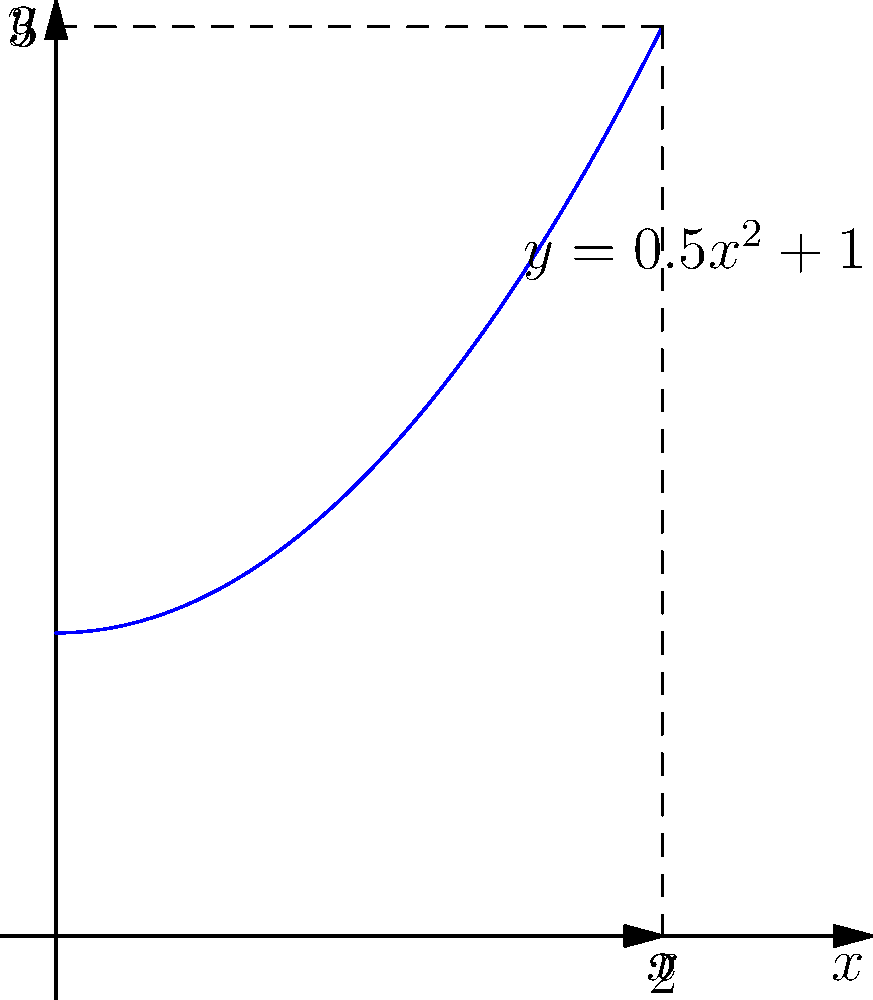As a sculptor inspired by your painted curves, you decide to create a three-dimensional form by rotating the curve $y = 0.5x^2 + 1$ around the x-axis from $x = 0$ to $x = 2$. Calculate the volume of this sculptural form using the method of shell integration. To solve this problem, we'll use the shell method for volume calculation. The steps are as follows:

1) The shell method formula is:
   $$V = 2\pi \int_a^b y \cdot x \, dx$$
   where $y$ is the function and $x$ is the distance from the axis of rotation.

2) In this case, $y = 0.5x^2 + 1$, $a = 0$, and $b = 2$.

3) Substituting into the formula:
   $$V = 2\pi \int_0^2 (0.5x^2 + 1) \cdot x \, dx$$

4) Distribute $x$ inside the parentheses:
   $$V = 2\pi \int_0^2 (0.5x^3 + x) \, dx$$

5) Integrate:
   $$V = 2\pi \left[\frac{1}{8}x^4 + \frac{1}{2}x^2\right]_0^2$$

6) Evaluate the integral:
   $$V = 2\pi \left[\left(\frac{1}{8}(2^4) + \frac{1}{2}(2^2)\right) - \left(\frac{1}{8}(0^4) + \frac{1}{2}(0^2)\right)\right]$$

7) Simplify:
   $$V = 2\pi \left[\frac{16}{8} + 2 - 0\right] = 2\pi \left[2 + 2\right] = 2\pi(4) = 8\pi$$

Therefore, the volume of the sculptural form is $8\pi$ cubic units.
Answer: $8\pi$ cubic units 